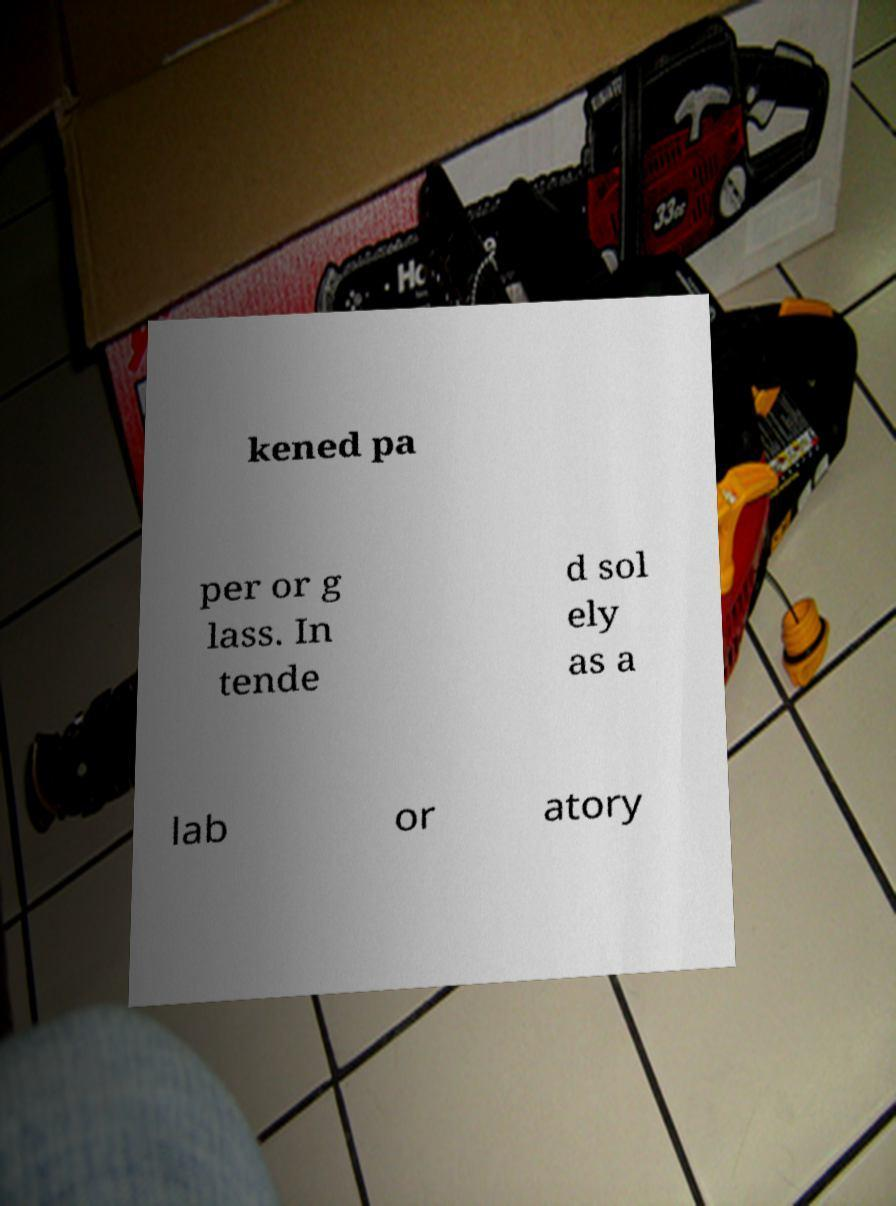What messages or text are displayed in this image? I need them in a readable, typed format. kened pa per or g lass. In tende d sol ely as a lab or atory 